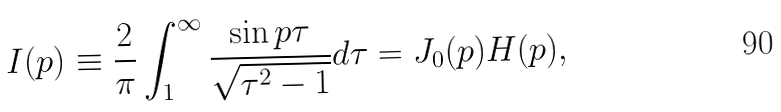<formula> <loc_0><loc_0><loc_500><loc_500>I ( p ) \equiv \frac { 2 } { \pi } \int ^ { \infty } _ { 1 } \frac { \sin p \tau } { \sqrt { \tau ^ { 2 } - 1 } } d \tau = J _ { 0 } ( p ) H ( p ) ,</formula> 